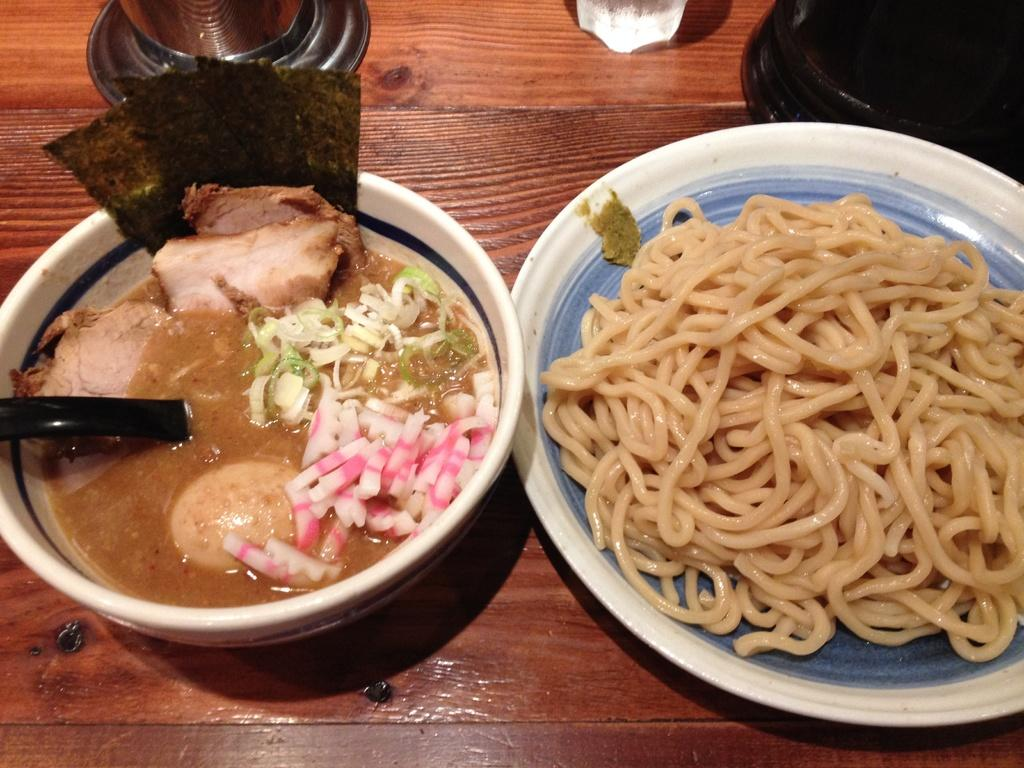What piece of furniture is present in the image? There is a table in the image. What type of food is on the table? There is a plate of noodles on the table. What is the bowl in the image used for? The bowl contains a food item, and it has a spoon in it. What type of beverage container is on the table? There is a glass on the table. How many snails can be seen crawling on the table in the image? There are no snails present in the image. What type of wool is used to make the tablecloth in the image? There is no tablecloth visible in the image, and therefore no wool can be identified. 